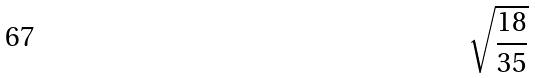Convert formula to latex. <formula><loc_0><loc_0><loc_500><loc_500>\sqrt { \frac { 1 8 } { 3 5 } }</formula> 